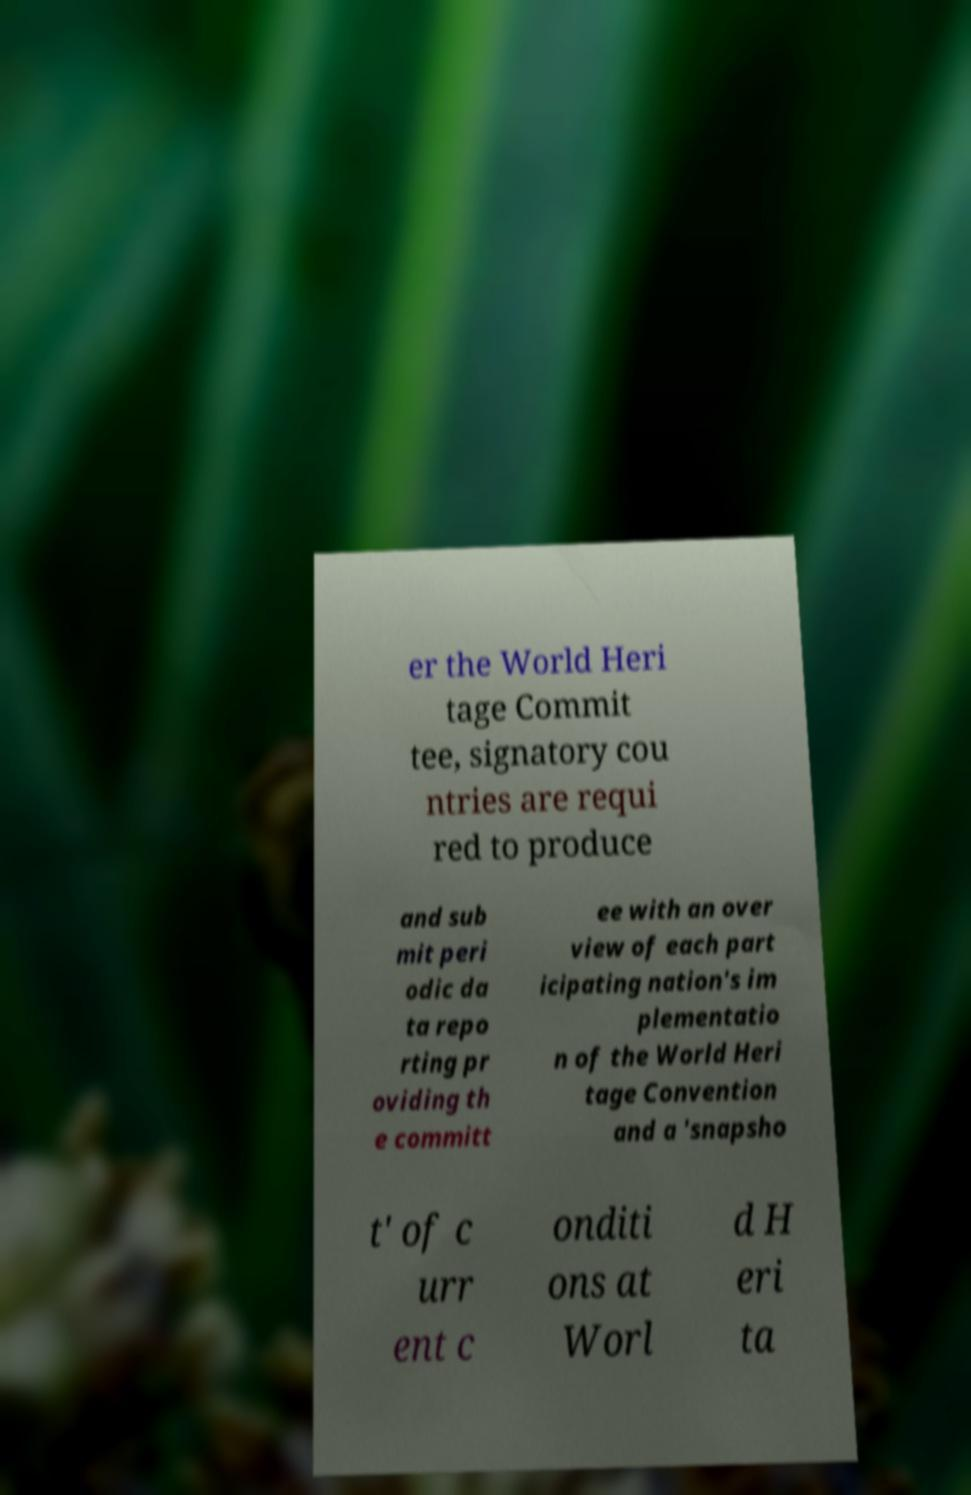I need the written content from this picture converted into text. Can you do that? er the World Heri tage Commit tee, signatory cou ntries are requi red to produce and sub mit peri odic da ta repo rting pr oviding th e committ ee with an over view of each part icipating nation's im plementatio n of the World Heri tage Convention and a 'snapsho t' of c urr ent c onditi ons at Worl d H eri ta 